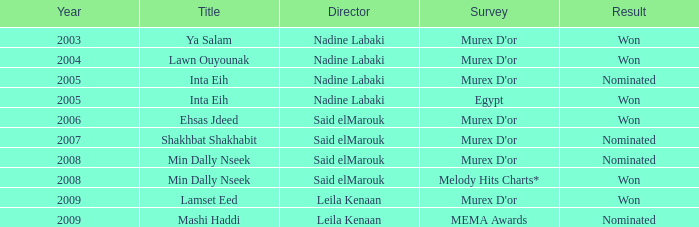Who claimed victory as the director with the min dally nseek title? Said elMarouk. 